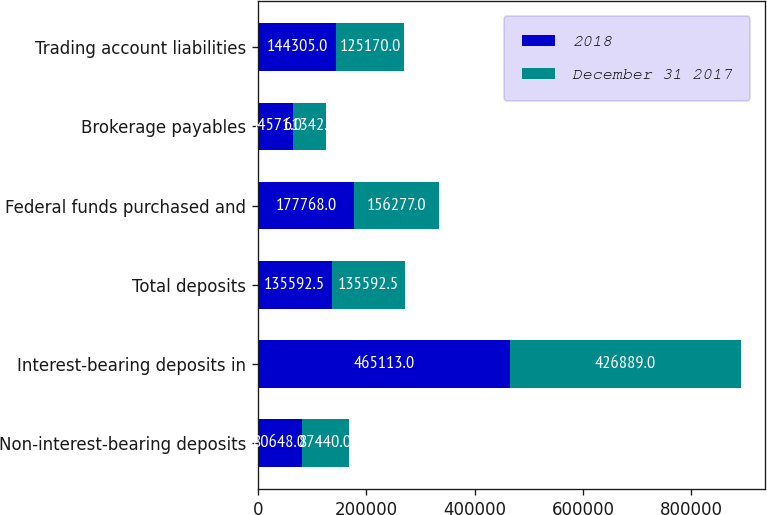Convert chart. <chart><loc_0><loc_0><loc_500><loc_500><stacked_bar_chart><ecel><fcel>Non-interest-bearing deposits<fcel>Interest-bearing deposits in<fcel>Total deposits<fcel>Federal funds purchased and<fcel>Brokerage payables<fcel>Trading account liabilities<nl><fcel>2018<fcel>80648<fcel>465113<fcel>135592<fcel>177768<fcel>64571<fcel>144305<nl><fcel>December 31 2017<fcel>87440<fcel>426889<fcel>135592<fcel>156277<fcel>61342<fcel>125170<nl></chart> 